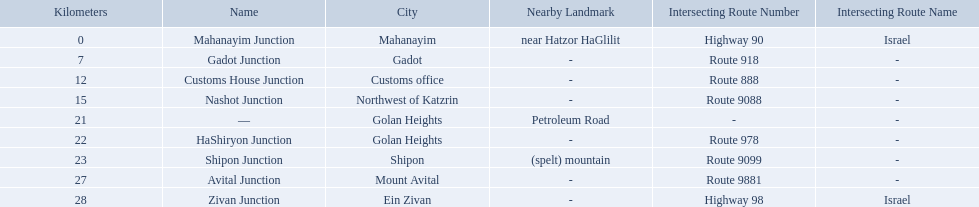What are all of the junction names? Mahanayim Junction, Gadot Junction, Customs House Junction, Nashot Junction, —, HaShiryon Junction, Shipon Junction, Avital Junction, Zivan Junction. What are their locations in kilometers? 0, 7, 12, 15, 21, 22, 23, 27, 28. Between shipon and avital, whicih is nashot closer to? Shipon Junction. Which junctions are located on numbered routes, and not highways or other types? Gadot Junction, Customs House Junction, Nashot Junction, HaShiryon Junction, Shipon Junction, Avital Junction. Of these junctions, which ones are located on routes with four digits (ex. route 9999)? Nashot Junction, Shipon Junction, Avital Junction. Of the remaining routes, which is located on shipon (spelt) mountain? Shipon Junction. How many kilometers away is shipon junction? 23. How many kilometers away is avital junction? 27. Which one is closer to nashot junction? Shipon Junction. Which intersecting routes are route 918 Route 918. What is the name? Gadot Junction. 